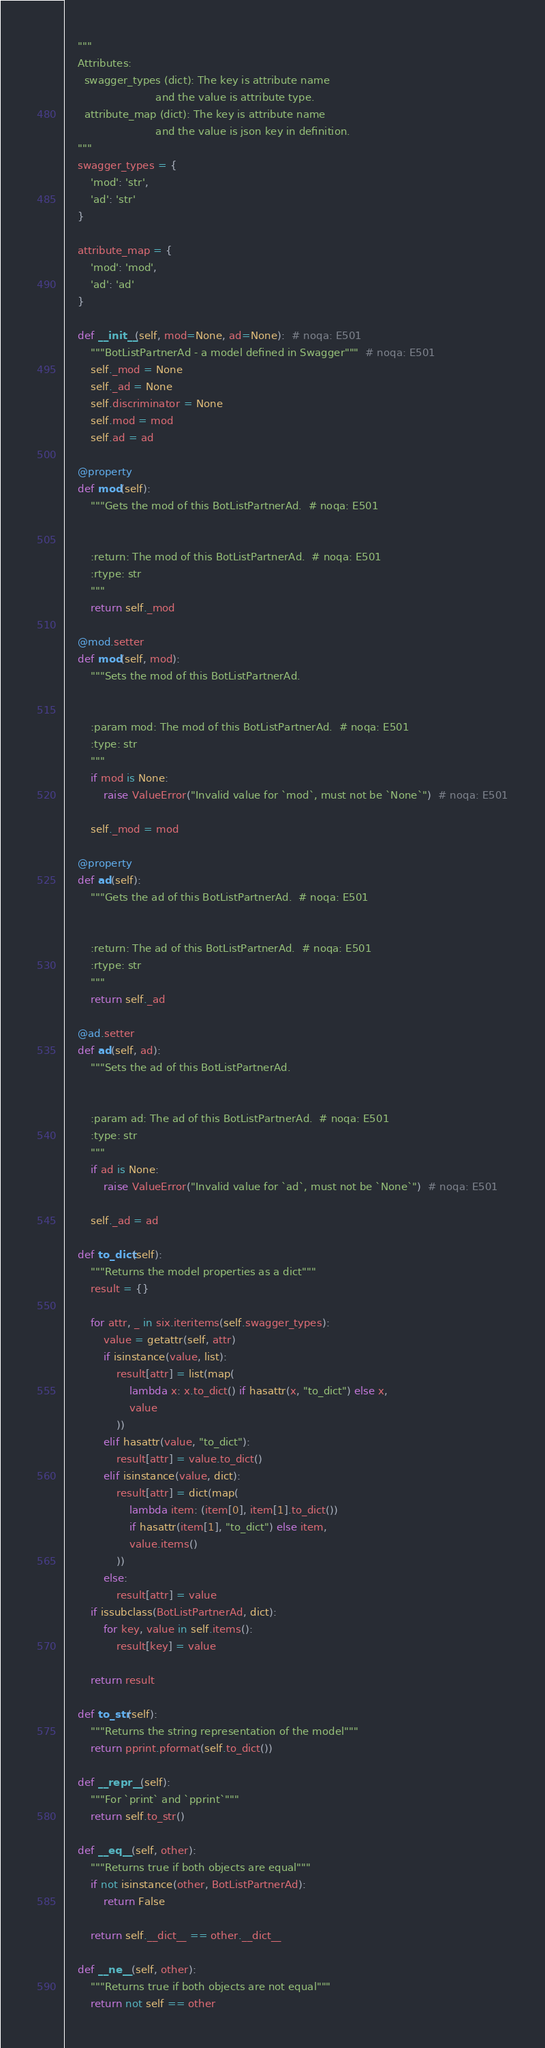Convert code to text. <code><loc_0><loc_0><loc_500><loc_500><_Python_>    """
    Attributes:
      swagger_types (dict): The key is attribute name
                            and the value is attribute type.
      attribute_map (dict): The key is attribute name
                            and the value is json key in definition.
    """
    swagger_types = {
        'mod': 'str',
        'ad': 'str'
    }

    attribute_map = {
        'mod': 'mod',
        'ad': 'ad'
    }

    def __init__(self, mod=None, ad=None):  # noqa: E501
        """BotListPartnerAd - a model defined in Swagger"""  # noqa: E501
        self._mod = None
        self._ad = None
        self.discriminator = None
        self.mod = mod
        self.ad = ad

    @property
    def mod(self):
        """Gets the mod of this BotListPartnerAd.  # noqa: E501


        :return: The mod of this BotListPartnerAd.  # noqa: E501
        :rtype: str
        """
        return self._mod

    @mod.setter
    def mod(self, mod):
        """Sets the mod of this BotListPartnerAd.


        :param mod: The mod of this BotListPartnerAd.  # noqa: E501
        :type: str
        """
        if mod is None:
            raise ValueError("Invalid value for `mod`, must not be `None`")  # noqa: E501

        self._mod = mod

    @property
    def ad(self):
        """Gets the ad of this BotListPartnerAd.  # noqa: E501


        :return: The ad of this BotListPartnerAd.  # noqa: E501
        :rtype: str
        """
        return self._ad

    @ad.setter
    def ad(self, ad):
        """Sets the ad of this BotListPartnerAd.


        :param ad: The ad of this BotListPartnerAd.  # noqa: E501
        :type: str
        """
        if ad is None:
            raise ValueError("Invalid value for `ad`, must not be `None`")  # noqa: E501

        self._ad = ad

    def to_dict(self):
        """Returns the model properties as a dict"""
        result = {}

        for attr, _ in six.iteritems(self.swagger_types):
            value = getattr(self, attr)
            if isinstance(value, list):
                result[attr] = list(map(
                    lambda x: x.to_dict() if hasattr(x, "to_dict") else x,
                    value
                ))
            elif hasattr(value, "to_dict"):
                result[attr] = value.to_dict()
            elif isinstance(value, dict):
                result[attr] = dict(map(
                    lambda item: (item[0], item[1].to_dict())
                    if hasattr(item[1], "to_dict") else item,
                    value.items()
                ))
            else:
                result[attr] = value
        if issubclass(BotListPartnerAd, dict):
            for key, value in self.items():
                result[key] = value

        return result

    def to_str(self):
        """Returns the string representation of the model"""
        return pprint.pformat(self.to_dict())

    def __repr__(self):
        """For `print` and `pprint`"""
        return self.to_str()

    def __eq__(self, other):
        """Returns true if both objects are equal"""
        if not isinstance(other, BotListPartnerAd):
            return False

        return self.__dict__ == other.__dict__

    def __ne__(self, other):
        """Returns true if both objects are not equal"""
        return not self == other
</code> 